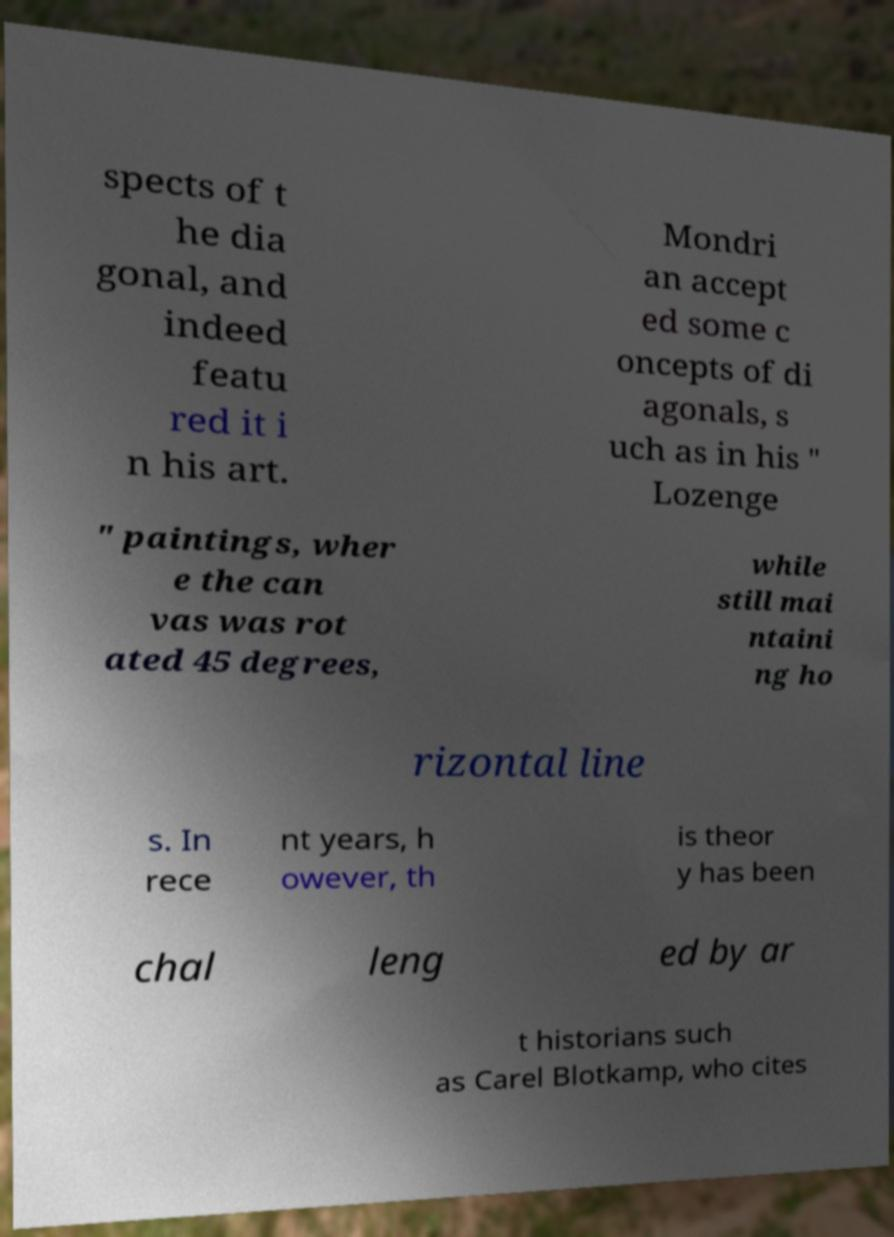Could you extract and type out the text from this image? spects of t he dia gonal, and indeed featu red it i n his art. Mondri an accept ed some c oncepts of di agonals, s uch as in his " Lozenge " paintings, wher e the can vas was rot ated 45 degrees, while still mai ntaini ng ho rizontal line s. In rece nt years, h owever, th is theor y has been chal leng ed by ar t historians such as Carel Blotkamp, who cites 